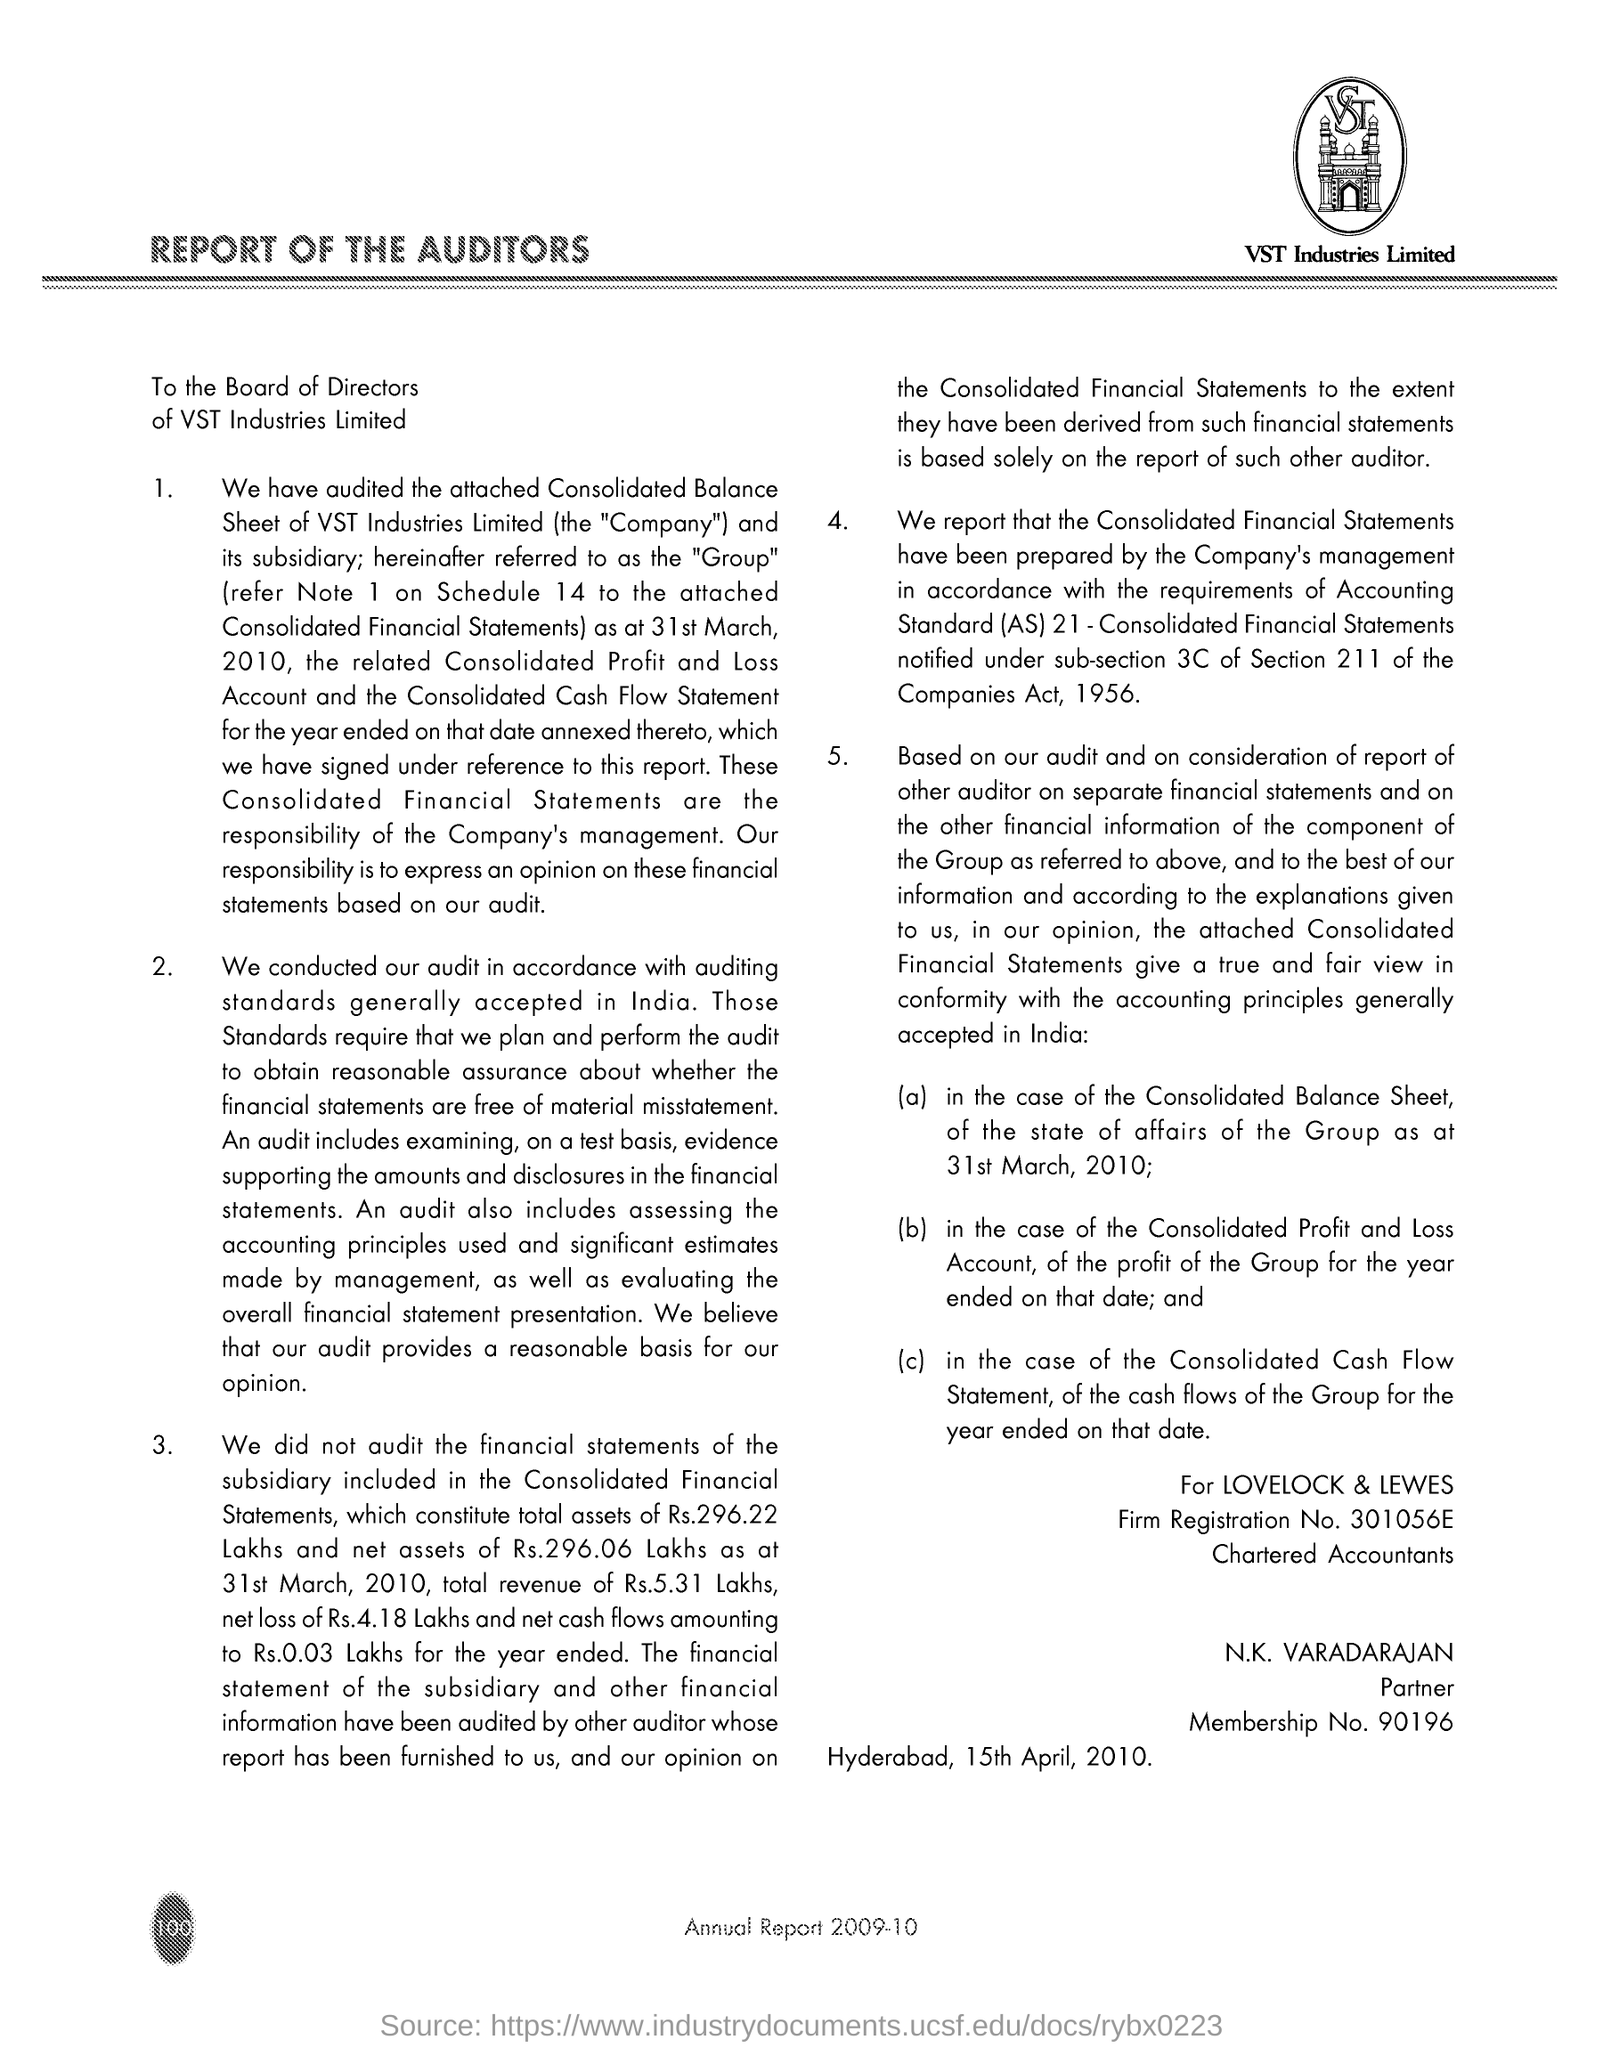What is the Firm Registration No. for LOVELOCK & LEWES given in the document?
Ensure brevity in your answer.  301056E. What is the Membership No. of N.K. Varadarajan?
Make the answer very short. 90196. What is the Place & Date mentioned in this document?
Give a very brief answer. Hyderabad, 15th April, 2010. 